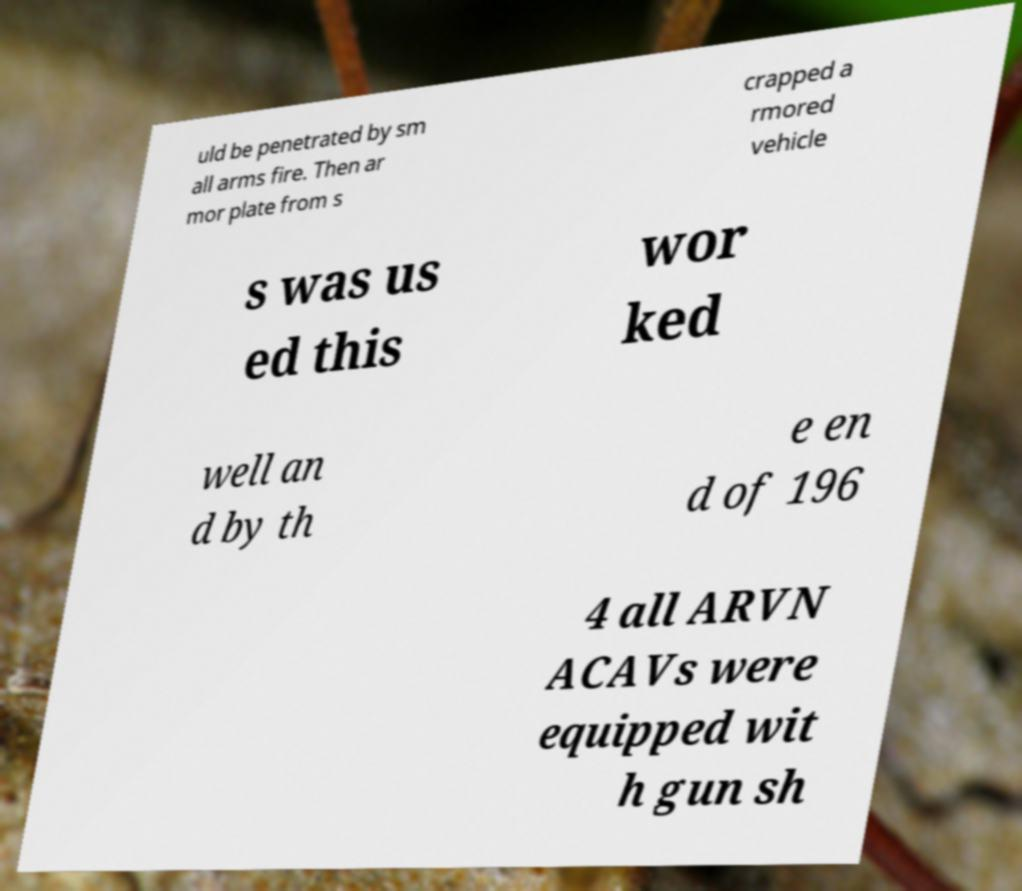There's text embedded in this image that I need extracted. Can you transcribe it verbatim? uld be penetrated by sm all arms fire. Then ar mor plate from s crapped a rmored vehicle s was us ed this wor ked well an d by th e en d of 196 4 all ARVN ACAVs were equipped wit h gun sh 